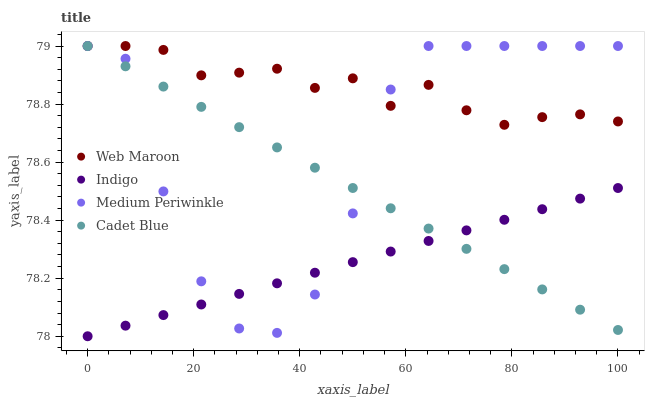Does Indigo have the minimum area under the curve?
Answer yes or no. Yes. Does Web Maroon have the maximum area under the curve?
Answer yes or no. Yes. Does Cadet Blue have the minimum area under the curve?
Answer yes or no. No. Does Cadet Blue have the maximum area under the curve?
Answer yes or no. No. Is Indigo the smoothest?
Answer yes or no. Yes. Is Medium Periwinkle the roughest?
Answer yes or no. Yes. Is Cadet Blue the smoothest?
Answer yes or no. No. Is Cadet Blue the roughest?
Answer yes or no. No. Does Indigo have the lowest value?
Answer yes or no. Yes. Does Cadet Blue have the lowest value?
Answer yes or no. No. Does Medium Periwinkle have the highest value?
Answer yes or no. Yes. Is Indigo less than Web Maroon?
Answer yes or no. Yes. Is Web Maroon greater than Indigo?
Answer yes or no. Yes. Does Cadet Blue intersect Indigo?
Answer yes or no. Yes. Is Cadet Blue less than Indigo?
Answer yes or no. No. Is Cadet Blue greater than Indigo?
Answer yes or no. No. Does Indigo intersect Web Maroon?
Answer yes or no. No. 